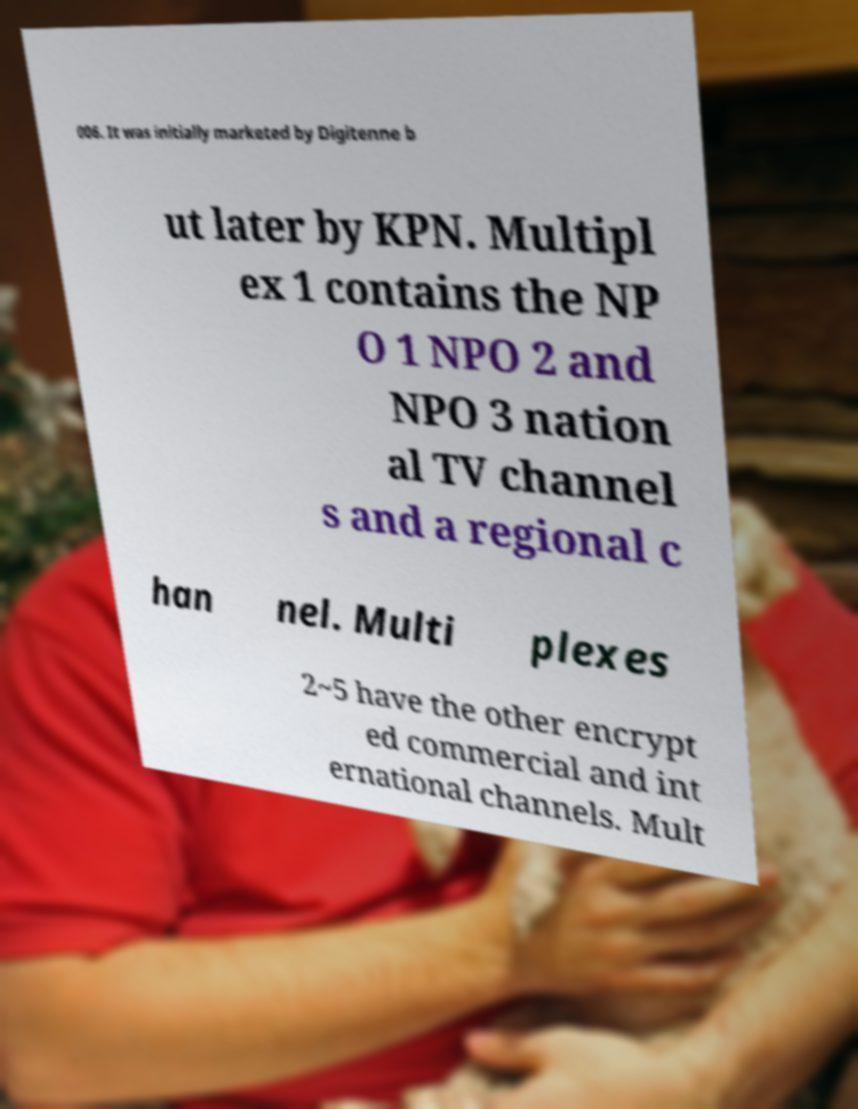Can you read and provide the text displayed in the image?This photo seems to have some interesting text. Can you extract and type it out for me? 006. It was initially marketed by Digitenne b ut later by KPN. Multipl ex 1 contains the NP O 1 NPO 2 and NPO 3 nation al TV channel s and a regional c han nel. Multi plexes 2~5 have the other encrypt ed commercial and int ernational channels. Mult 